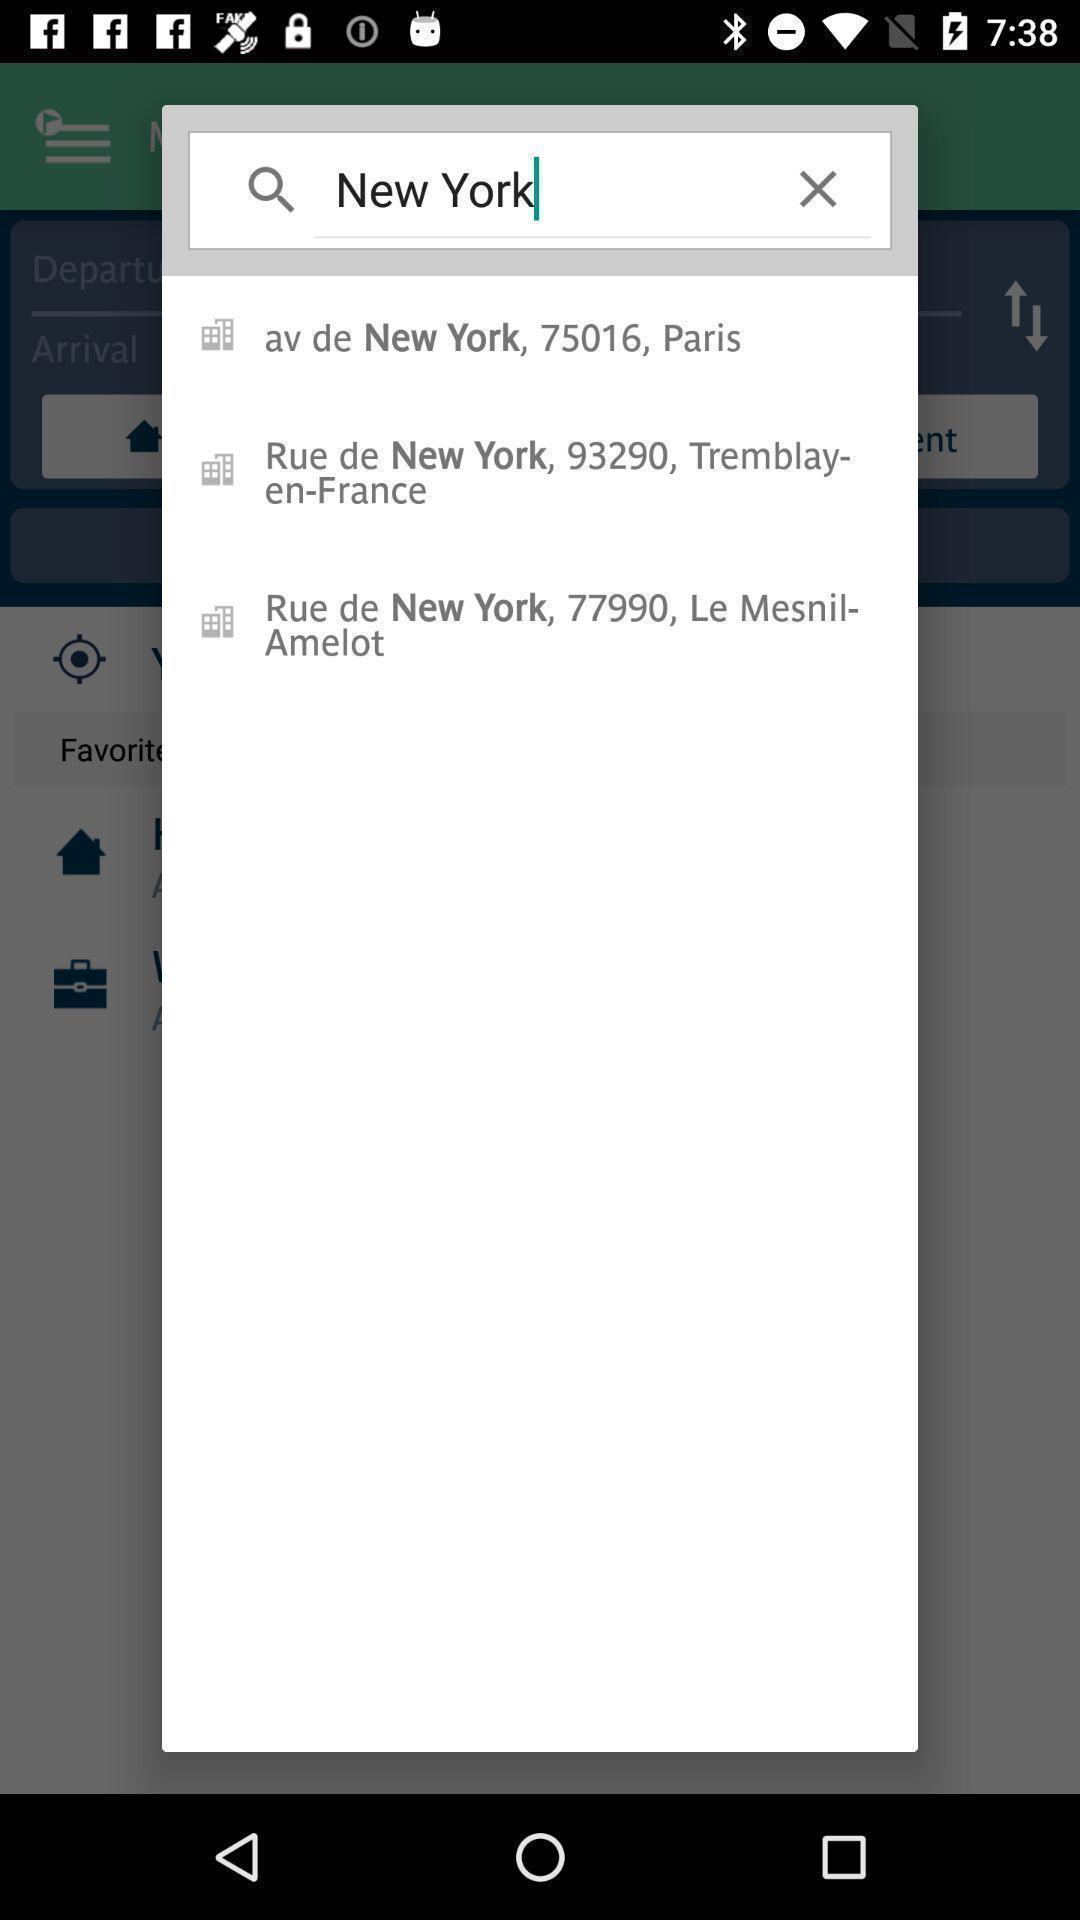Provide a description of this screenshot. Search bar in choice of transportation app. 